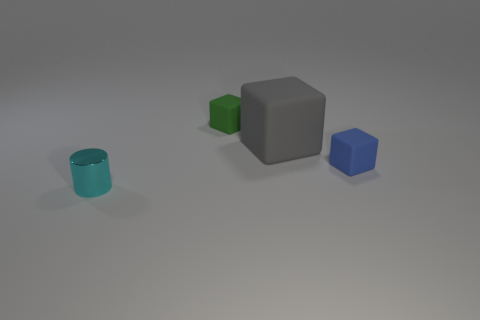There is a green thing that is the same material as the big cube; what shape is it?
Provide a succinct answer. Cube. Is the number of big cubes in front of the gray cube less than the number of big blocks?
Make the answer very short. Yes. There is a small matte object left of the small blue cube; what is its color?
Your response must be concise. Green. Are there any other tiny blue matte things that have the same shape as the tiny blue thing?
Give a very brief answer. No. How many small yellow rubber objects are the same shape as the gray matte thing?
Your answer should be compact. 0. Is the color of the cylinder the same as the big matte block?
Offer a very short reply. No. Is the number of small gray metallic cylinders less than the number of small metallic things?
Your answer should be compact. Yes. There is a tiny cube that is to the right of the green object; what is its material?
Provide a short and direct response. Rubber. There is a cyan thing that is the same size as the blue object; what is its material?
Your answer should be very brief. Metal. What is the material of the tiny object behind the small object to the right of the tiny matte cube that is to the left of the tiny blue matte cube?
Offer a terse response. Rubber. 